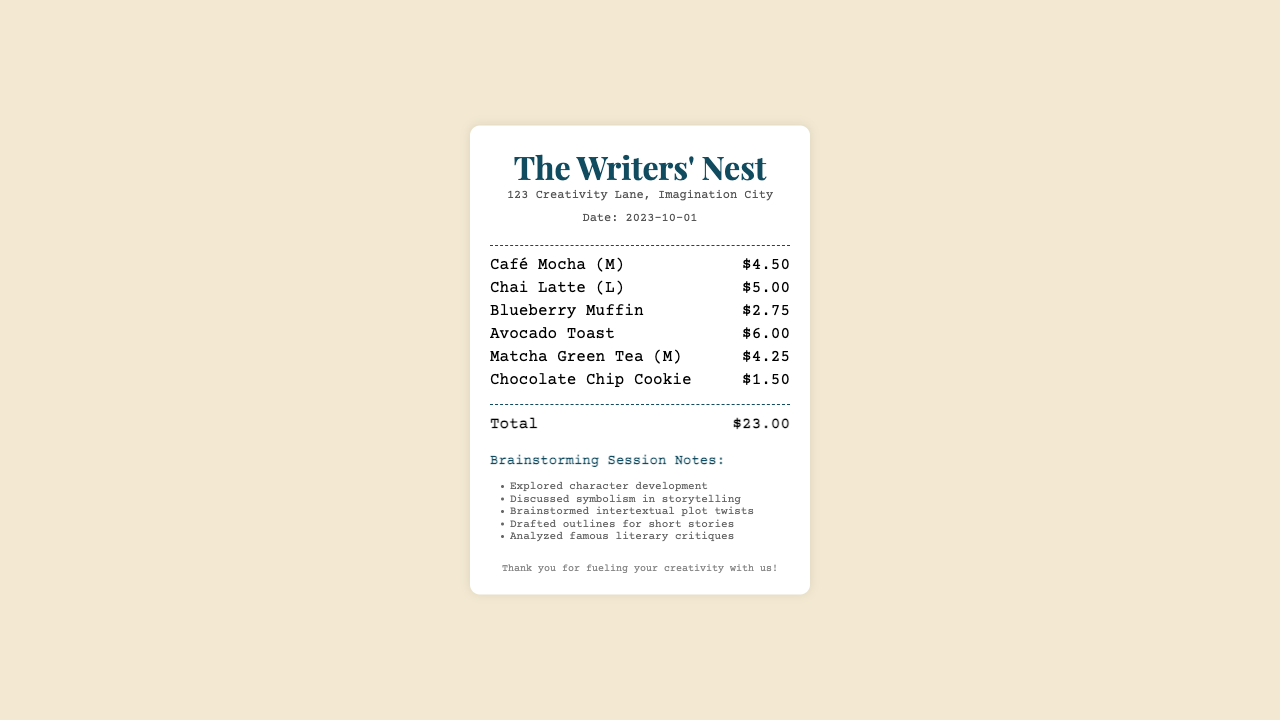What is the date of the receipt? The date listed in the receipt is provided in the document.
Answer: 2023-10-01 What is the total amount spent? The total amount is specified at the bottom of the receipt.
Answer: $23.00 Which drink costs the most? The drinks are listed with their prices, and the one with the highest cost is indicated.
Answer: Chai Latte (L) How many snacks were ordered? The items list includes both drinks and snacks, and the snacks must be counted separately.
Answer: 2 What type of session is noted in the document? The header in the notes section describes the purpose of the gathering.
Answer: Brainstorming Session What flavor is the muffin ordered? The specific snack listed includes its flavor, which is mentioned in the document.
Answer: Blueberry What is one topic discussed during the brainstorming session? The notes section lists several topics explored during the session.
Answer: Character development Which drink is a matcha flavor? The drinks list provides information about the flavors of the beverages ordered.
Answer: Matcha Green Tea (M) How many items are there in total? The receipts list the individual items, and they need to be counted to arrive at the total.
Answer: 6 